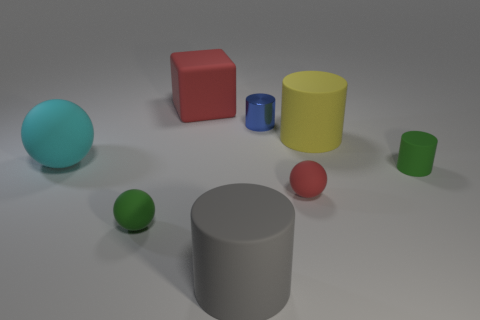Is there any other thing that has the same material as the blue object?
Make the answer very short. No. What material is the red ball?
Offer a very short reply. Rubber. There is a big matte cube; does it have the same color as the small rubber ball on the right side of the large red block?
Offer a very short reply. Yes. How big is the cylinder that is both on the left side of the small red rubber object and behind the small red matte object?
Ensure brevity in your answer.  Small. What shape is the gray thing that is made of the same material as the large yellow thing?
Provide a short and direct response. Cylinder. Is the material of the yellow cylinder the same as the red object in front of the rubber block?
Offer a very short reply. Yes. Is there a sphere that is left of the big rubber object that is behind the tiny blue cylinder?
Your answer should be compact. Yes. What material is the other big thing that is the same shape as the gray rubber thing?
Ensure brevity in your answer.  Rubber. There is a big cylinder in front of the big cyan ball; what number of rubber cylinders are in front of it?
Offer a terse response. 0. Is there anything else of the same color as the cube?
Your answer should be compact. Yes. 